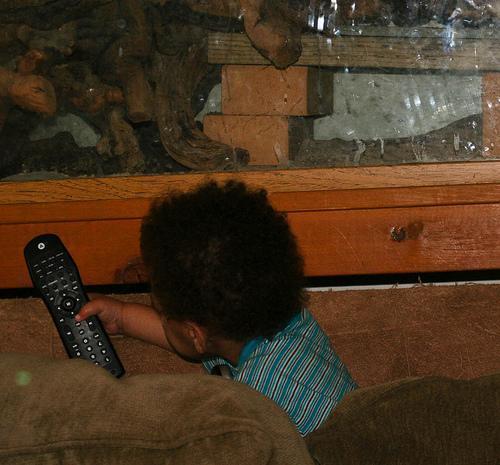How many toddlers are in the picture?
Give a very brief answer. 1. How many remotes are in the picture?
Give a very brief answer. 1. 